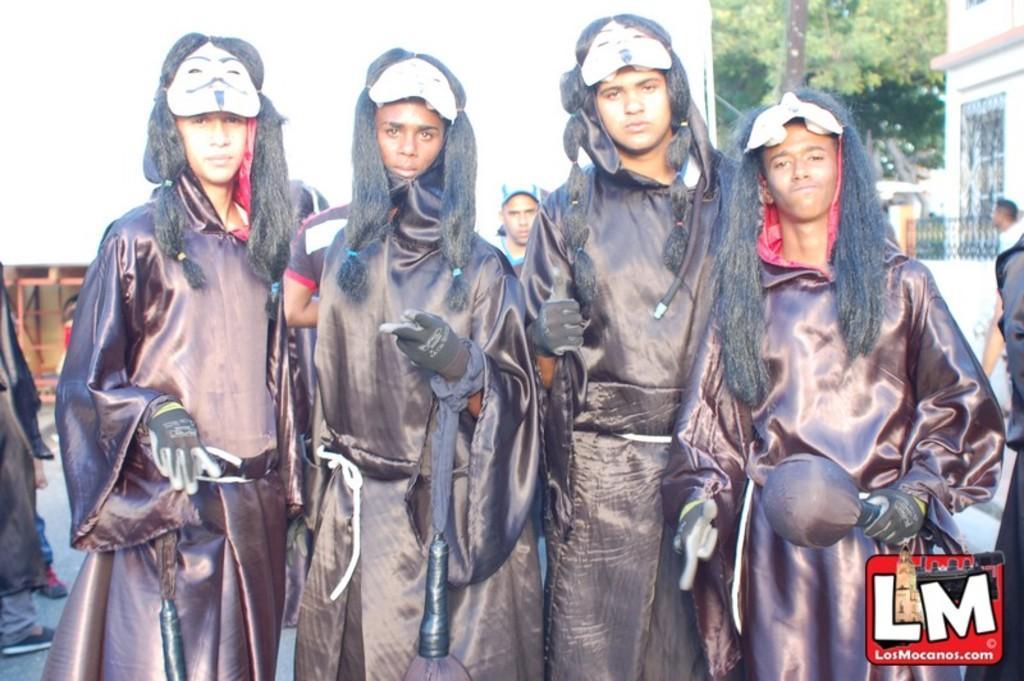Describe this image in one or two sentences. As we can see in the image there are few people here and there, white color wall, building, gate and trees. 